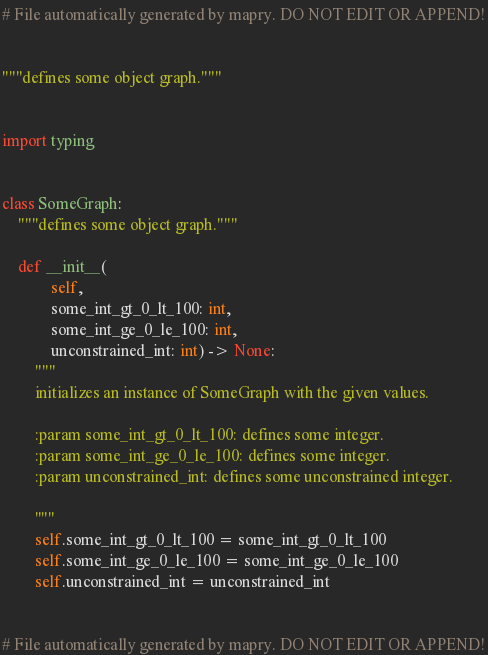<code> <loc_0><loc_0><loc_500><loc_500><_Python_># File automatically generated by mapry. DO NOT EDIT OR APPEND!


"""defines some object graph."""


import typing


class SomeGraph:
    """defines some object graph."""

    def __init__(
            self,
            some_int_gt_0_lt_100: int,
            some_int_ge_0_le_100: int,
            unconstrained_int: int) -> None:
        """
        initializes an instance of SomeGraph with the given values.

        :param some_int_gt_0_lt_100: defines some integer.
        :param some_int_ge_0_le_100: defines some integer.
        :param unconstrained_int: defines some unconstrained integer.

        """
        self.some_int_gt_0_lt_100 = some_int_gt_0_lt_100
        self.some_int_ge_0_le_100 = some_int_ge_0_le_100
        self.unconstrained_int = unconstrained_int


# File automatically generated by mapry. DO NOT EDIT OR APPEND!
</code> 